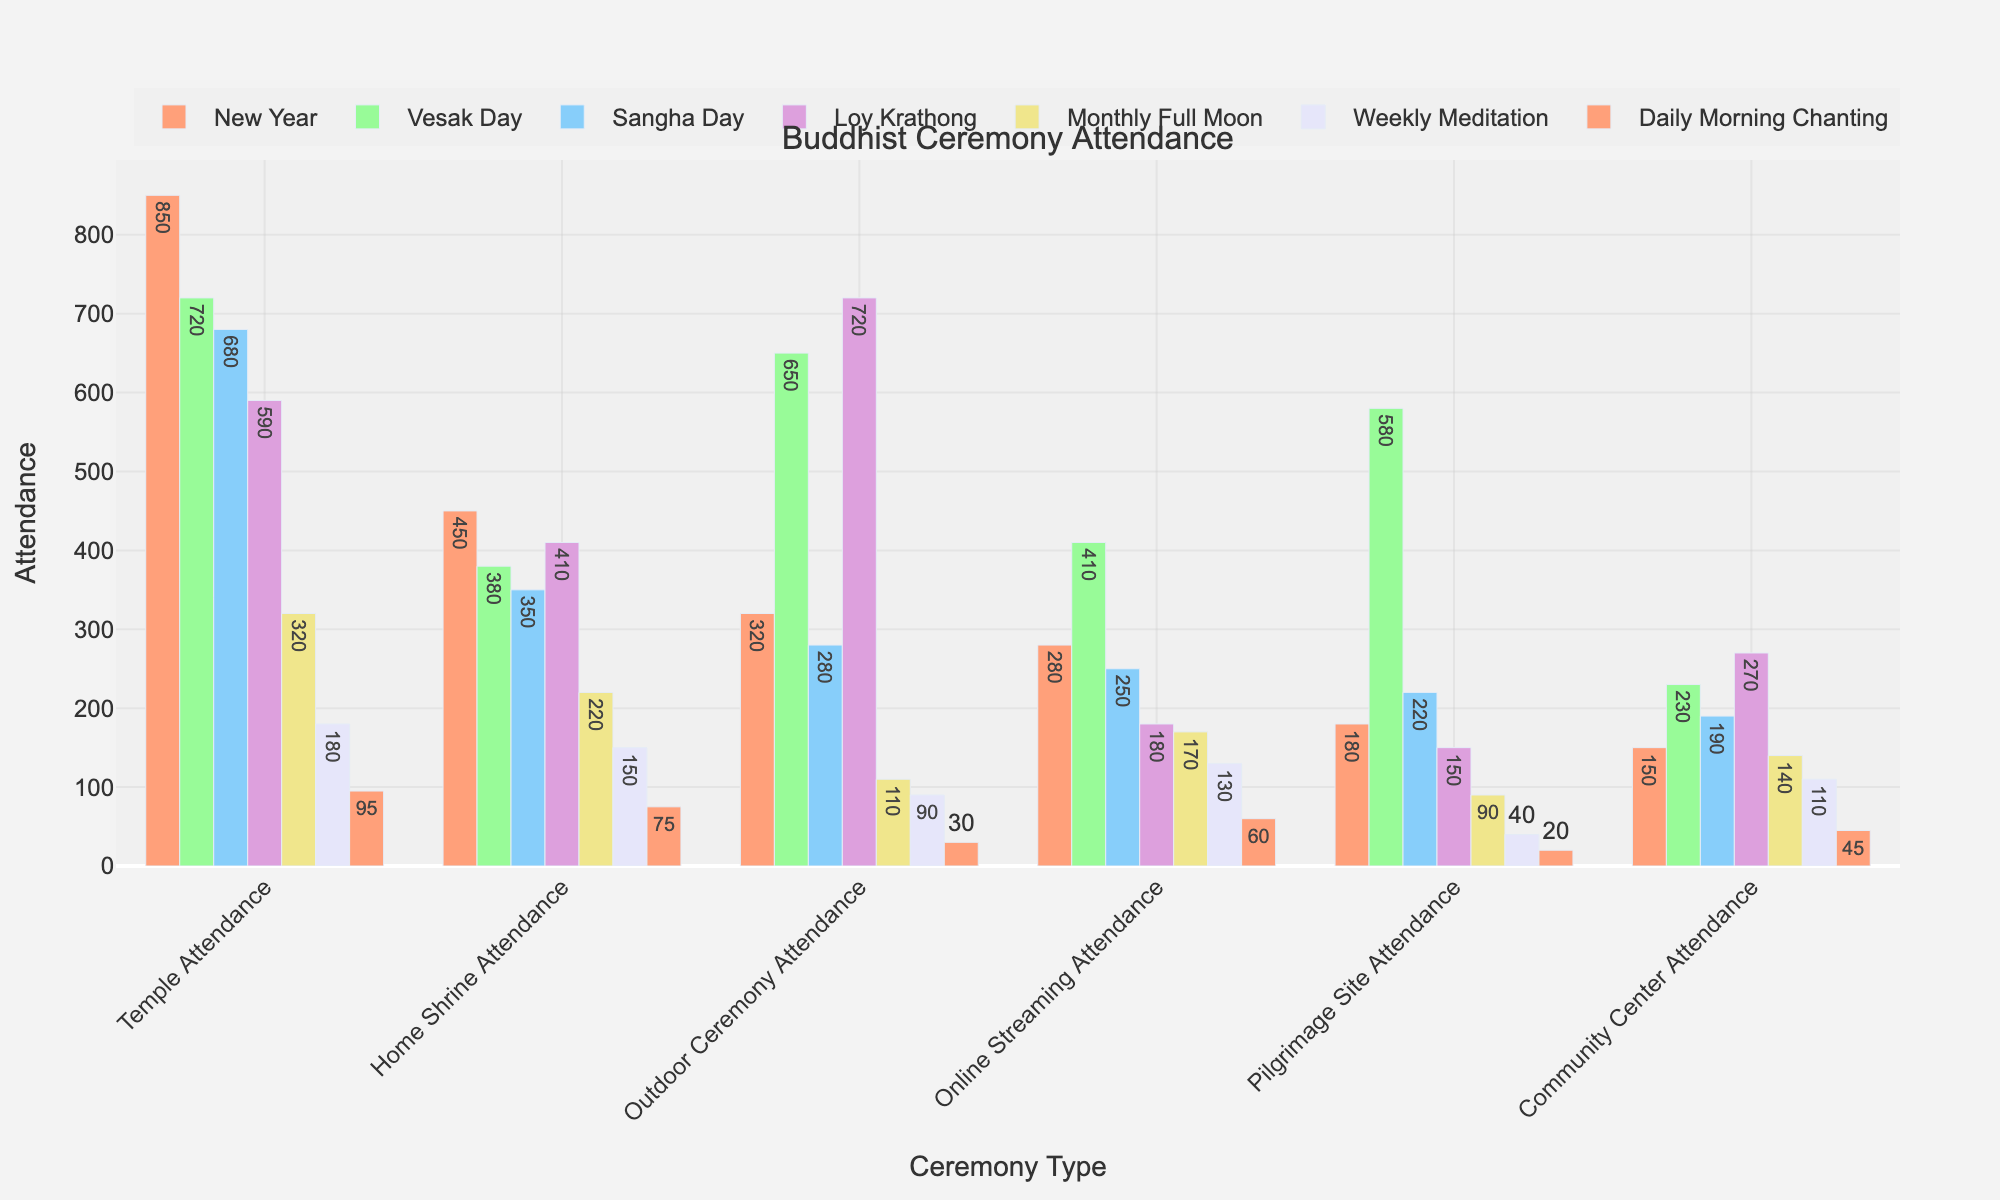Which ceremony type has the highest overall attendance? To find the ceremony type with the highest overall attendance, sum up the attendance numbers for each ceremony type across all venues. The calculations for each ceremony type show that New Year has the highest overall sum.
Answer: New Year Which venue has the highest attendance for Sangha Day? For Sangha Day, compare the attendance numbers across all venues: Temple Attendance (680), Home Shrine Attendance (350), Outdoor Ceremony Attendance (280), Online Streaming Attendance (250), Pilgrimage Site Attendance (220), Community Center Attendance (190). Outdoor Ceremony Attendance is the highest.
Answer: Outdoor Ceremony Attendance What is the average attendance for Weekly Meditation across all listed venues? Add up all the attendance numbers for Weekly Meditation and divide by the number of venues: (180 + 150 + 90 + 130 + 40 + 110) / 6. This gives the average attendance.
Answer: 116.67 For which ceremony type is outdoor ceremony attendance almost equal to online streaming attendance? Compare the attendance numbers for Outdoor Ceremony and Online Streaming for each ceremony: Find the pair where the numbers are close. For Pilgrimage Site attendance, the numbers are 150 (Outdoor) and 180 (Online Streaming), which are nearly equal.
Answer: Pilgrimage Site How much higher is the temple attendance for New Year compared to community center attendance for Vesak Day? Compare the two values: Temple Attendance for New Year (850) and Community Center Attendance for Vesak Day (230). The difference is 850 - 230.
Answer: 620 Which ceremony type has the lowest home shrine attendance? Check the Home Shrine Attendance numbers for each ceremony: The lowest attendance number is found in Daily Morning Chanting (75).
Answer: Daily Morning Chanting By how much does the online streaming attendance for Weekly Meditation exceed the pilgrimage site attendance for the same ceremony? Compare the attendance numbers: Online Streaming (130) and Pilgrimage Site (40). The difference is 130 - 40.
Answer: 90 How does the community center attendance for Loy Krathong compare with the temple attendance for Monthly Full Moon? Compare the two values: Community Center Attendance for Loy Krathong (270) and Temple Attendance for Monthly Full Moon (320). The Community Center Attendance for Loy Krathong is less than Temple Attendance for Monthly Full Moon.
Answer: Less What is the total attendance for Daily Morning Chanting across all venues? Sum up the attendance numbers for Daily Morning Chanting: 95 (Temple) + 75 (Home Shrine) + 30 (Outdoor) + 60 (Online Streaming) + 20 (Pilgrimage Site) + 45 (Community Center).
Answer: 325 